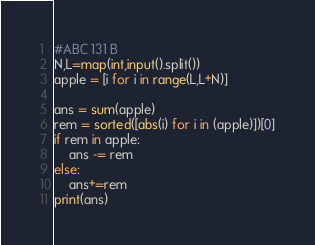Convert code to text. <code><loc_0><loc_0><loc_500><loc_500><_Python_>#ABC 131 B
N,L=map(int,input().split())
apple = [i for i in range(L,L+N)]

ans = sum(apple) 
rem = sorted([abs(i) for i in (apple)])[0]
if rem in apple:
    ans -= rem
else:
    ans+=rem
print(ans)</code> 